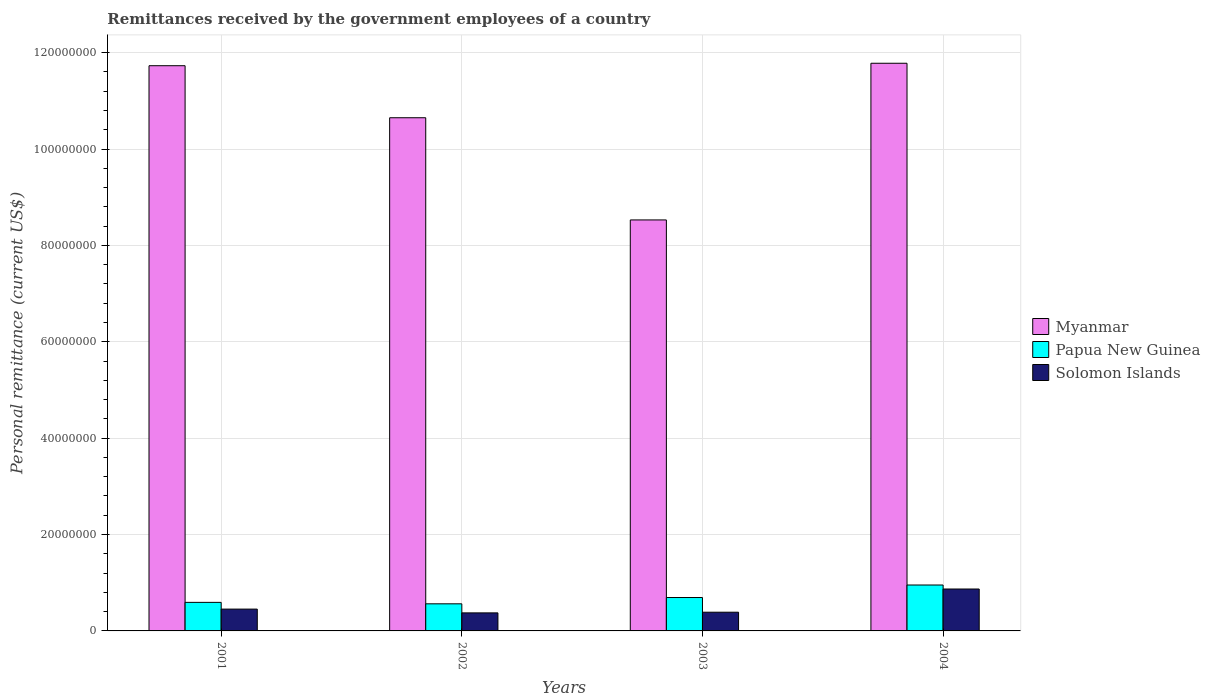How many different coloured bars are there?
Provide a short and direct response. 3. Are the number of bars per tick equal to the number of legend labels?
Make the answer very short. Yes. How many bars are there on the 4th tick from the left?
Your answer should be compact. 3. How many bars are there on the 1st tick from the right?
Your answer should be compact. 3. What is the label of the 2nd group of bars from the left?
Offer a terse response. 2002. What is the remittances received by the government employees in Myanmar in 2004?
Offer a terse response. 1.18e+08. Across all years, what is the maximum remittances received by the government employees in Solomon Islands?
Make the answer very short. 8.70e+06. Across all years, what is the minimum remittances received by the government employees in Myanmar?
Your answer should be very brief. 8.53e+07. In which year was the remittances received by the government employees in Papua New Guinea minimum?
Make the answer very short. 2002. What is the total remittances received by the government employees in Myanmar in the graph?
Provide a succinct answer. 4.27e+08. What is the difference between the remittances received by the government employees in Papua New Guinea in 2001 and that in 2002?
Ensure brevity in your answer.  3.02e+05. What is the difference between the remittances received by the government employees in Solomon Islands in 2002 and the remittances received by the government employees in Myanmar in 2004?
Offer a terse response. -1.14e+08. What is the average remittances received by the government employees in Solomon Islands per year?
Your answer should be compact. 5.21e+06. In the year 2003, what is the difference between the remittances received by the government employees in Papua New Guinea and remittances received by the government employees in Solomon Islands?
Your answer should be very brief. 3.05e+06. What is the ratio of the remittances received by the government employees in Myanmar in 2001 to that in 2002?
Your response must be concise. 1.1. Is the remittances received by the government employees in Solomon Islands in 2002 less than that in 2003?
Offer a terse response. Yes. What is the difference between the highest and the second highest remittances received by the government employees in Solomon Islands?
Offer a very short reply. 4.17e+06. What is the difference between the highest and the lowest remittances received by the government employees in Myanmar?
Your response must be concise. 3.25e+07. What does the 1st bar from the left in 2004 represents?
Give a very brief answer. Myanmar. What does the 2nd bar from the right in 2001 represents?
Ensure brevity in your answer.  Papua New Guinea. Is it the case that in every year, the sum of the remittances received by the government employees in Papua New Guinea and remittances received by the government employees in Solomon Islands is greater than the remittances received by the government employees in Myanmar?
Provide a short and direct response. No. How many years are there in the graph?
Keep it short and to the point. 4. What is the difference between two consecutive major ticks on the Y-axis?
Provide a succinct answer. 2.00e+07. Does the graph contain any zero values?
Make the answer very short. No. Where does the legend appear in the graph?
Your answer should be very brief. Center right. What is the title of the graph?
Offer a terse response. Remittances received by the government employees of a country. What is the label or title of the X-axis?
Offer a very short reply. Years. What is the label or title of the Y-axis?
Keep it short and to the point. Personal remittance (current US$). What is the Personal remittance (current US$) in Myanmar in 2001?
Offer a terse response. 1.17e+08. What is the Personal remittance (current US$) of Papua New Guinea in 2001?
Offer a terse response. 5.92e+06. What is the Personal remittance (current US$) in Solomon Islands in 2001?
Your answer should be very brief. 4.53e+06. What is the Personal remittance (current US$) of Myanmar in 2002?
Provide a short and direct response. 1.06e+08. What is the Personal remittance (current US$) in Papua New Guinea in 2002?
Make the answer very short. 5.62e+06. What is the Personal remittance (current US$) of Solomon Islands in 2002?
Ensure brevity in your answer.  3.74e+06. What is the Personal remittance (current US$) of Myanmar in 2003?
Offer a very short reply. 8.53e+07. What is the Personal remittance (current US$) in Papua New Guinea in 2003?
Ensure brevity in your answer.  6.93e+06. What is the Personal remittance (current US$) of Solomon Islands in 2003?
Make the answer very short. 3.88e+06. What is the Personal remittance (current US$) of Myanmar in 2004?
Your answer should be very brief. 1.18e+08. What is the Personal remittance (current US$) in Papua New Guinea in 2004?
Provide a short and direct response. 9.53e+06. What is the Personal remittance (current US$) in Solomon Islands in 2004?
Offer a very short reply. 8.70e+06. Across all years, what is the maximum Personal remittance (current US$) of Myanmar?
Make the answer very short. 1.18e+08. Across all years, what is the maximum Personal remittance (current US$) in Papua New Guinea?
Offer a very short reply. 9.53e+06. Across all years, what is the maximum Personal remittance (current US$) in Solomon Islands?
Keep it short and to the point. 8.70e+06. Across all years, what is the minimum Personal remittance (current US$) of Myanmar?
Provide a succinct answer. 8.53e+07. Across all years, what is the minimum Personal remittance (current US$) in Papua New Guinea?
Keep it short and to the point. 5.62e+06. Across all years, what is the minimum Personal remittance (current US$) in Solomon Islands?
Give a very brief answer. 3.74e+06. What is the total Personal remittance (current US$) of Myanmar in the graph?
Your answer should be compact. 4.27e+08. What is the total Personal remittance (current US$) of Papua New Guinea in the graph?
Make the answer very short. 2.80e+07. What is the total Personal remittance (current US$) in Solomon Islands in the graph?
Provide a short and direct response. 2.08e+07. What is the difference between the Personal remittance (current US$) in Myanmar in 2001 and that in 2002?
Make the answer very short. 1.08e+07. What is the difference between the Personal remittance (current US$) in Papua New Guinea in 2001 and that in 2002?
Your answer should be very brief. 3.02e+05. What is the difference between the Personal remittance (current US$) in Solomon Islands in 2001 and that in 2002?
Offer a very short reply. 7.85e+05. What is the difference between the Personal remittance (current US$) of Myanmar in 2001 and that in 2003?
Your response must be concise. 3.20e+07. What is the difference between the Personal remittance (current US$) of Papua New Guinea in 2001 and that in 2003?
Offer a terse response. -1.01e+06. What is the difference between the Personal remittance (current US$) of Solomon Islands in 2001 and that in 2003?
Provide a short and direct response. 6.47e+05. What is the difference between the Personal remittance (current US$) of Myanmar in 2001 and that in 2004?
Your answer should be very brief. -5.09e+05. What is the difference between the Personal remittance (current US$) of Papua New Guinea in 2001 and that in 2004?
Provide a succinct answer. -3.60e+06. What is the difference between the Personal remittance (current US$) in Solomon Islands in 2001 and that in 2004?
Give a very brief answer. -4.17e+06. What is the difference between the Personal remittance (current US$) in Myanmar in 2002 and that in 2003?
Keep it short and to the point. 2.12e+07. What is the difference between the Personal remittance (current US$) in Papua New Guinea in 2002 and that in 2003?
Your response must be concise. -1.31e+06. What is the difference between the Personal remittance (current US$) in Solomon Islands in 2002 and that in 2003?
Your answer should be very brief. -1.38e+05. What is the difference between the Personal remittance (current US$) in Myanmar in 2002 and that in 2004?
Provide a short and direct response. -1.13e+07. What is the difference between the Personal remittance (current US$) of Papua New Guinea in 2002 and that in 2004?
Offer a very short reply. -3.90e+06. What is the difference between the Personal remittance (current US$) in Solomon Islands in 2002 and that in 2004?
Provide a succinct answer. -4.95e+06. What is the difference between the Personal remittance (current US$) of Myanmar in 2003 and that in 2004?
Make the answer very short. -3.25e+07. What is the difference between the Personal remittance (current US$) in Papua New Guinea in 2003 and that in 2004?
Offer a very short reply. -2.60e+06. What is the difference between the Personal remittance (current US$) in Solomon Islands in 2003 and that in 2004?
Ensure brevity in your answer.  -4.82e+06. What is the difference between the Personal remittance (current US$) of Myanmar in 2001 and the Personal remittance (current US$) of Papua New Guinea in 2002?
Your answer should be very brief. 1.12e+08. What is the difference between the Personal remittance (current US$) in Myanmar in 2001 and the Personal remittance (current US$) in Solomon Islands in 2002?
Make the answer very short. 1.14e+08. What is the difference between the Personal remittance (current US$) in Papua New Guinea in 2001 and the Personal remittance (current US$) in Solomon Islands in 2002?
Your answer should be very brief. 2.18e+06. What is the difference between the Personal remittance (current US$) of Myanmar in 2001 and the Personal remittance (current US$) of Papua New Guinea in 2003?
Offer a very short reply. 1.10e+08. What is the difference between the Personal remittance (current US$) in Myanmar in 2001 and the Personal remittance (current US$) in Solomon Islands in 2003?
Give a very brief answer. 1.13e+08. What is the difference between the Personal remittance (current US$) in Papua New Guinea in 2001 and the Personal remittance (current US$) in Solomon Islands in 2003?
Make the answer very short. 2.04e+06. What is the difference between the Personal remittance (current US$) of Myanmar in 2001 and the Personal remittance (current US$) of Papua New Guinea in 2004?
Provide a short and direct response. 1.08e+08. What is the difference between the Personal remittance (current US$) of Myanmar in 2001 and the Personal remittance (current US$) of Solomon Islands in 2004?
Offer a terse response. 1.09e+08. What is the difference between the Personal remittance (current US$) in Papua New Guinea in 2001 and the Personal remittance (current US$) in Solomon Islands in 2004?
Provide a succinct answer. -2.77e+06. What is the difference between the Personal remittance (current US$) of Myanmar in 2002 and the Personal remittance (current US$) of Papua New Guinea in 2003?
Ensure brevity in your answer.  9.96e+07. What is the difference between the Personal remittance (current US$) of Myanmar in 2002 and the Personal remittance (current US$) of Solomon Islands in 2003?
Give a very brief answer. 1.03e+08. What is the difference between the Personal remittance (current US$) of Papua New Guinea in 2002 and the Personal remittance (current US$) of Solomon Islands in 2003?
Give a very brief answer. 1.74e+06. What is the difference between the Personal remittance (current US$) of Myanmar in 2002 and the Personal remittance (current US$) of Papua New Guinea in 2004?
Keep it short and to the point. 9.70e+07. What is the difference between the Personal remittance (current US$) in Myanmar in 2002 and the Personal remittance (current US$) in Solomon Islands in 2004?
Give a very brief answer. 9.78e+07. What is the difference between the Personal remittance (current US$) of Papua New Guinea in 2002 and the Personal remittance (current US$) of Solomon Islands in 2004?
Your answer should be very brief. -3.07e+06. What is the difference between the Personal remittance (current US$) of Myanmar in 2003 and the Personal remittance (current US$) of Papua New Guinea in 2004?
Your answer should be very brief. 7.58e+07. What is the difference between the Personal remittance (current US$) in Myanmar in 2003 and the Personal remittance (current US$) in Solomon Islands in 2004?
Keep it short and to the point. 7.66e+07. What is the difference between the Personal remittance (current US$) of Papua New Guinea in 2003 and the Personal remittance (current US$) of Solomon Islands in 2004?
Ensure brevity in your answer.  -1.77e+06. What is the average Personal remittance (current US$) of Myanmar per year?
Provide a short and direct response. 1.07e+08. What is the average Personal remittance (current US$) of Papua New Guinea per year?
Provide a succinct answer. 7.00e+06. What is the average Personal remittance (current US$) in Solomon Islands per year?
Your answer should be very brief. 5.21e+06. In the year 2001, what is the difference between the Personal remittance (current US$) of Myanmar and Personal remittance (current US$) of Papua New Guinea?
Keep it short and to the point. 1.11e+08. In the year 2001, what is the difference between the Personal remittance (current US$) of Myanmar and Personal remittance (current US$) of Solomon Islands?
Keep it short and to the point. 1.13e+08. In the year 2001, what is the difference between the Personal remittance (current US$) of Papua New Guinea and Personal remittance (current US$) of Solomon Islands?
Your response must be concise. 1.40e+06. In the year 2002, what is the difference between the Personal remittance (current US$) in Myanmar and Personal remittance (current US$) in Papua New Guinea?
Offer a very short reply. 1.01e+08. In the year 2002, what is the difference between the Personal remittance (current US$) of Myanmar and Personal remittance (current US$) of Solomon Islands?
Give a very brief answer. 1.03e+08. In the year 2002, what is the difference between the Personal remittance (current US$) of Papua New Guinea and Personal remittance (current US$) of Solomon Islands?
Ensure brevity in your answer.  1.88e+06. In the year 2003, what is the difference between the Personal remittance (current US$) in Myanmar and Personal remittance (current US$) in Papua New Guinea?
Provide a short and direct response. 7.83e+07. In the year 2003, what is the difference between the Personal remittance (current US$) of Myanmar and Personal remittance (current US$) of Solomon Islands?
Keep it short and to the point. 8.14e+07. In the year 2003, what is the difference between the Personal remittance (current US$) of Papua New Guinea and Personal remittance (current US$) of Solomon Islands?
Offer a very short reply. 3.05e+06. In the year 2004, what is the difference between the Personal remittance (current US$) in Myanmar and Personal remittance (current US$) in Papua New Guinea?
Give a very brief answer. 1.08e+08. In the year 2004, what is the difference between the Personal remittance (current US$) in Myanmar and Personal remittance (current US$) in Solomon Islands?
Your answer should be very brief. 1.09e+08. In the year 2004, what is the difference between the Personal remittance (current US$) of Papua New Guinea and Personal remittance (current US$) of Solomon Islands?
Your answer should be very brief. 8.30e+05. What is the ratio of the Personal remittance (current US$) of Myanmar in 2001 to that in 2002?
Offer a terse response. 1.1. What is the ratio of the Personal remittance (current US$) of Papua New Guinea in 2001 to that in 2002?
Offer a very short reply. 1.05. What is the ratio of the Personal remittance (current US$) in Solomon Islands in 2001 to that in 2002?
Ensure brevity in your answer.  1.21. What is the ratio of the Personal remittance (current US$) of Myanmar in 2001 to that in 2003?
Provide a succinct answer. 1.38. What is the ratio of the Personal remittance (current US$) in Papua New Guinea in 2001 to that in 2003?
Offer a terse response. 0.85. What is the ratio of the Personal remittance (current US$) in Papua New Guinea in 2001 to that in 2004?
Keep it short and to the point. 0.62. What is the ratio of the Personal remittance (current US$) in Solomon Islands in 2001 to that in 2004?
Keep it short and to the point. 0.52. What is the ratio of the Personal remittance (current US$) of Myanmar in 2002 to that in 2003?
Offer a terse response. 1.25. What is the ratio of the Personal remittance (current US$) of Papua New Guinea in 2002 to that in 2003?
Provide a succinct answer. 0.81. What is the ratio of the Personal remittance (current US$) of Solomon Islands in 2002 to that in 2003?
Ensure brevity in your answer.  0.96. What is the ratio of the Personal remittance (current US$) in Myanmar in 2002 to that in 2004?
Ensure brevity in your answer.  0.9. What is the ratio of the Personal remittance (current US$) in Papua New Guinea in 2002 to that in 2004?
Make the answer very short. 0.59. What is the ratio of the Personal remittance (current US$) in Solomon Islands in 2002 to that in 2004?
Provide a succinct answer. 0.43. What is the ratio of the Personal remittance (current US$) of Myanmar in 2003 to that in 2004?
Your response must be concise. 0.72. What is the ratio of the Personal remittance (current US$) in Papua New Guinea in 2003 to that in 2004?
Your response must be concise. 0.73. What is the ratio of the Personal remittance (current US$) in Solomon Islands in 2003 to that in 2004?
Give a very brief answer. 0.45. What is the difference between the highest and the second highest Personal remittance (current US$) in Myanmar?
Provide a succinct answer. 5.09e+05. What is the difference between the highest and the second highest Personal remittance (current US$) in Papua New Guinea?
Make the answer very short. 2.60e+06. What is the difference between the highest and the second highest Personal remittance (current US$) of Solomon Islands?
Your response must be concise. 4.17e+06. What is the difference between the highest and the lowest Personal remittance (current US$) in Myanmar?
Provide a succinct answer. 3.25e+07. What is the difference between the highest and the lowest Personal remittance (current US$) in Papua New Guinea?
Keep it short and to the point. 3.90e+06. What is the difference between the highest and the lowest Personal remittance (current US$) in Solomon Islands?
Provide a succinct answer. 4.95e+06. 